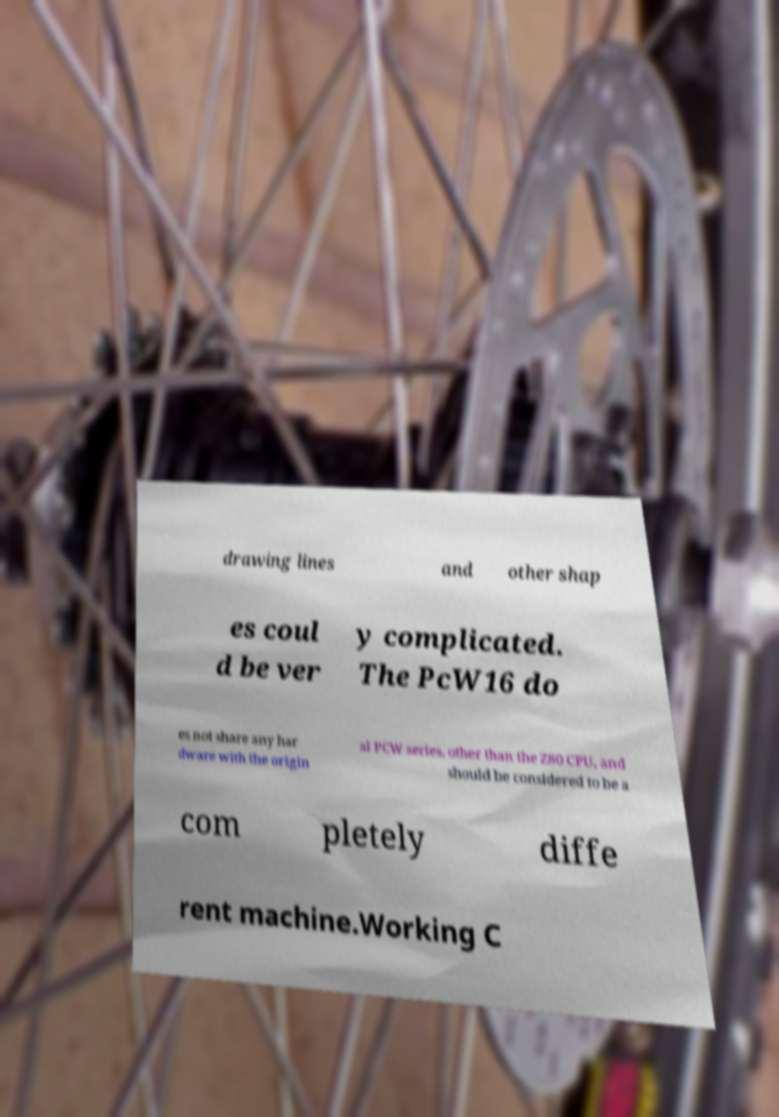For documentation purposes, I need the text within this image transcribed. Could you provide that? drawing lines and other shap es coul d be ver y complicated. The PcW16 do es not share any har dware with the origin al PCW series, other than the Z80 CPU, and should be considered to be a com pletely diffe rent machine.Working C 